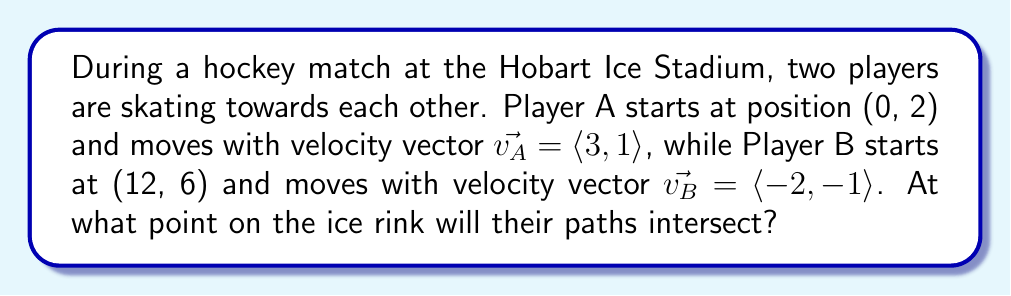Teach me how to tackle this problem. To find the intersection point, we need to set up and solve a system of equations representing the players' trajectories.

1. Set up parametric equations for each player's position:
   Player A: $x_A = 0 + 3t$, $y_A = 2 + t$
   Player B: $x_B = 12 - 2s$, $y_B = 6 - s$

2. At the intersection point, the coordinates will be equal:
   $x_A = x_B$ and $y_A = y_B$

3. This gives us the system of equations:
   $$\begin{cases}
   0 + 3t = 12 - 2s \\
   2 + t = 6 - s
   \end{cases}$$

4. Solve the second equation for $t$:
   $t = 4 - s$

5. Substitute this into the first equation:
   $3(4 - s) = 12 - 2s$
   $12 - 3s = 12 - 2s$
   $-3s = -2s$
   $-s = 0$
   $s = 0$

6. Substitute $s = 0$ back into $t = 4 - s$:
   $t = 4$

7. Use either $t$ or $s$ to find the intersection point:
   Using $t$: $x = 0 + 3(4) = 12$, $y = 2 + 4 = 6$

Therefore, the intersection point is (12, 6).
Answer: (12, 6) 